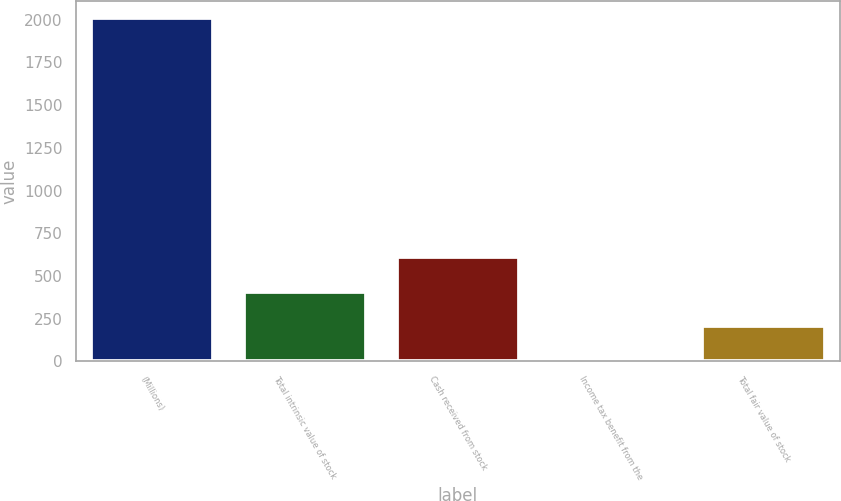<chart> <loc_0><loc_0><loc_500><loc_500><bar_chart><fcel>(Millions)<fcel>Total intrinsic value of stock<fcel>Cash received from stock<fcel>Income tax benefit from the<fcel>Total fair value of stock<nl><fcel>2010<fcel>409.2<fcel>609.3<fcel>9<fcel>209.1<nl></chart> 